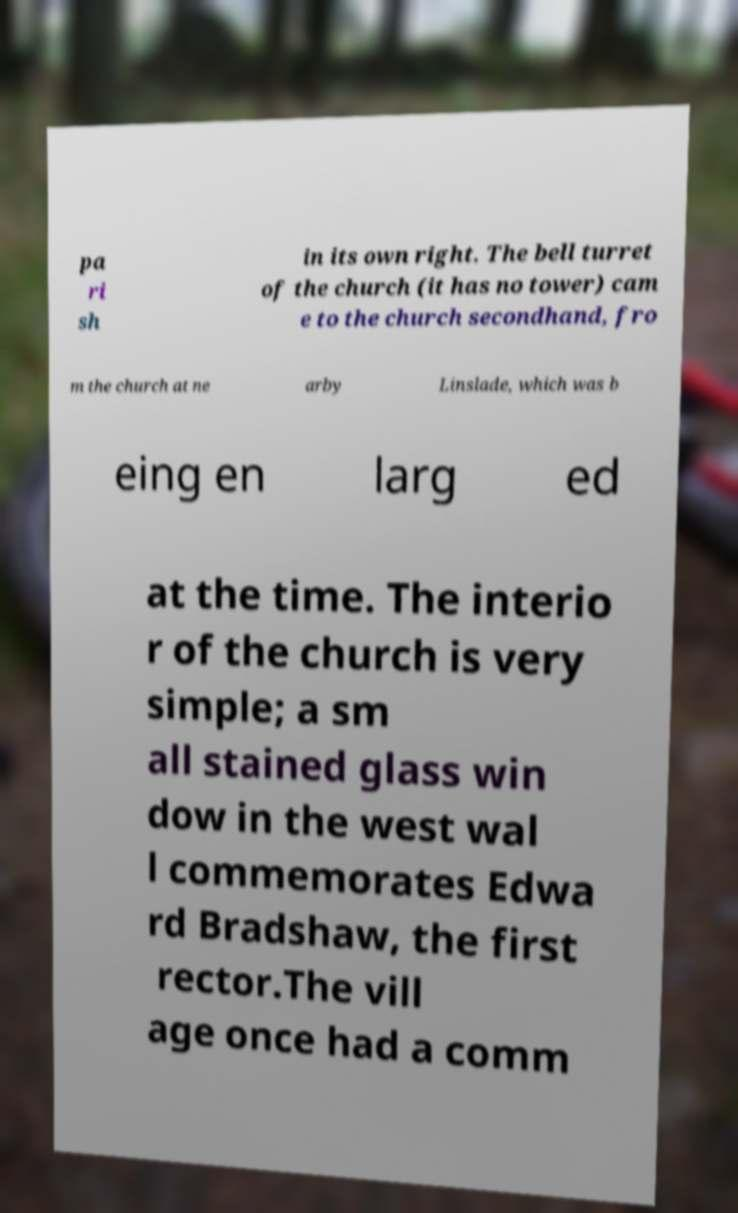There's text embedded in this image that I need extracted. Can you transcribe it verbatim? pa ri sh in its own right. The bell turret of the church (it has no tower) cam e to the church secondhand, fro m the church at ne arby Linslade, which was b eing en larg ed at the time. The interio r of the church is very simple; a sm all stained glass win dow in the west wal l commemorates Edwa rd Bradshaw, the first rector.The vill age once had a comm 